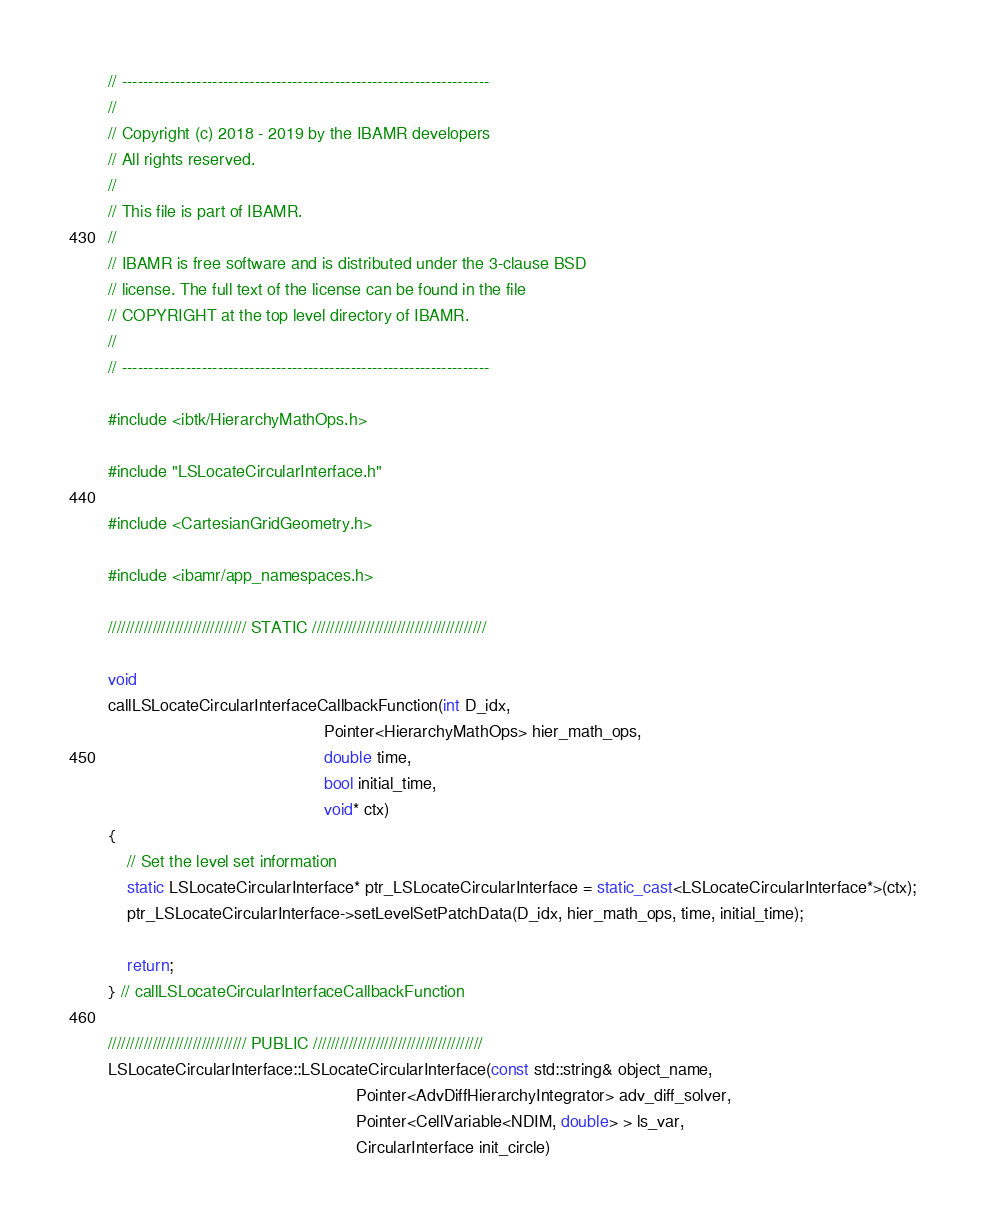<code> <loc_0><loc_0><loc_500><loc_500><_C++_>// ---------------------------------------------------------------------
//
// Copyright (c) 2018 - 2019 by the IBAMR developers
// All rights reserved.
//
// This file is part of IBAMR.
//
// IBAMR is free software and is distributed under the 3-clause BSD
// license. The full text of the license can be found in the file
// COPYRIGHT at the top level directory of IBAMR.
//
// ---------------------------------------------------------------------

#include <ibtk/HierarchyMathOps.h>

#include "LSLocateCircularInterface.h"

#include <CartesianGridGeometry.h>

#include <ibamr/app_namespaces.h>

/////////////////////////////// STATIC ///////////////////////////////////////

void
callLSLocateCircularInterfaceCallbackFunction(int D_idx,
                                              Pointer<HierarchyMathOps> hier_math_ops,
                                              double time,
                                              bool initial_time,
                                              void* ctx)
{
    // Set the level set information
    static LSLocateCircularInterface* ptr_LSLocateCircularInterface = static_cast<LSLocateCircularInterface*>(ctx);
    ptr_LSLocateCircularInterface->setLevelSetPatchData(D_idx, hier_math_ops, time, initial_time);

    return;
} // callLSLocateCircularInterfaceCallbackFunction

/////////////////////////////// PUBLIC //////////////////////////////////////
LSLocateCircularInterface::LSLocateCircularInterface(const std::string& object_name,
                                                     Pointer<AdvDiffHierarchyIntegrator> adv_diff_solver,
                                                     Pointer<CellVariable<NDIM, double> > ls_var,
                                                     CircularInterface init_circle)</code> 